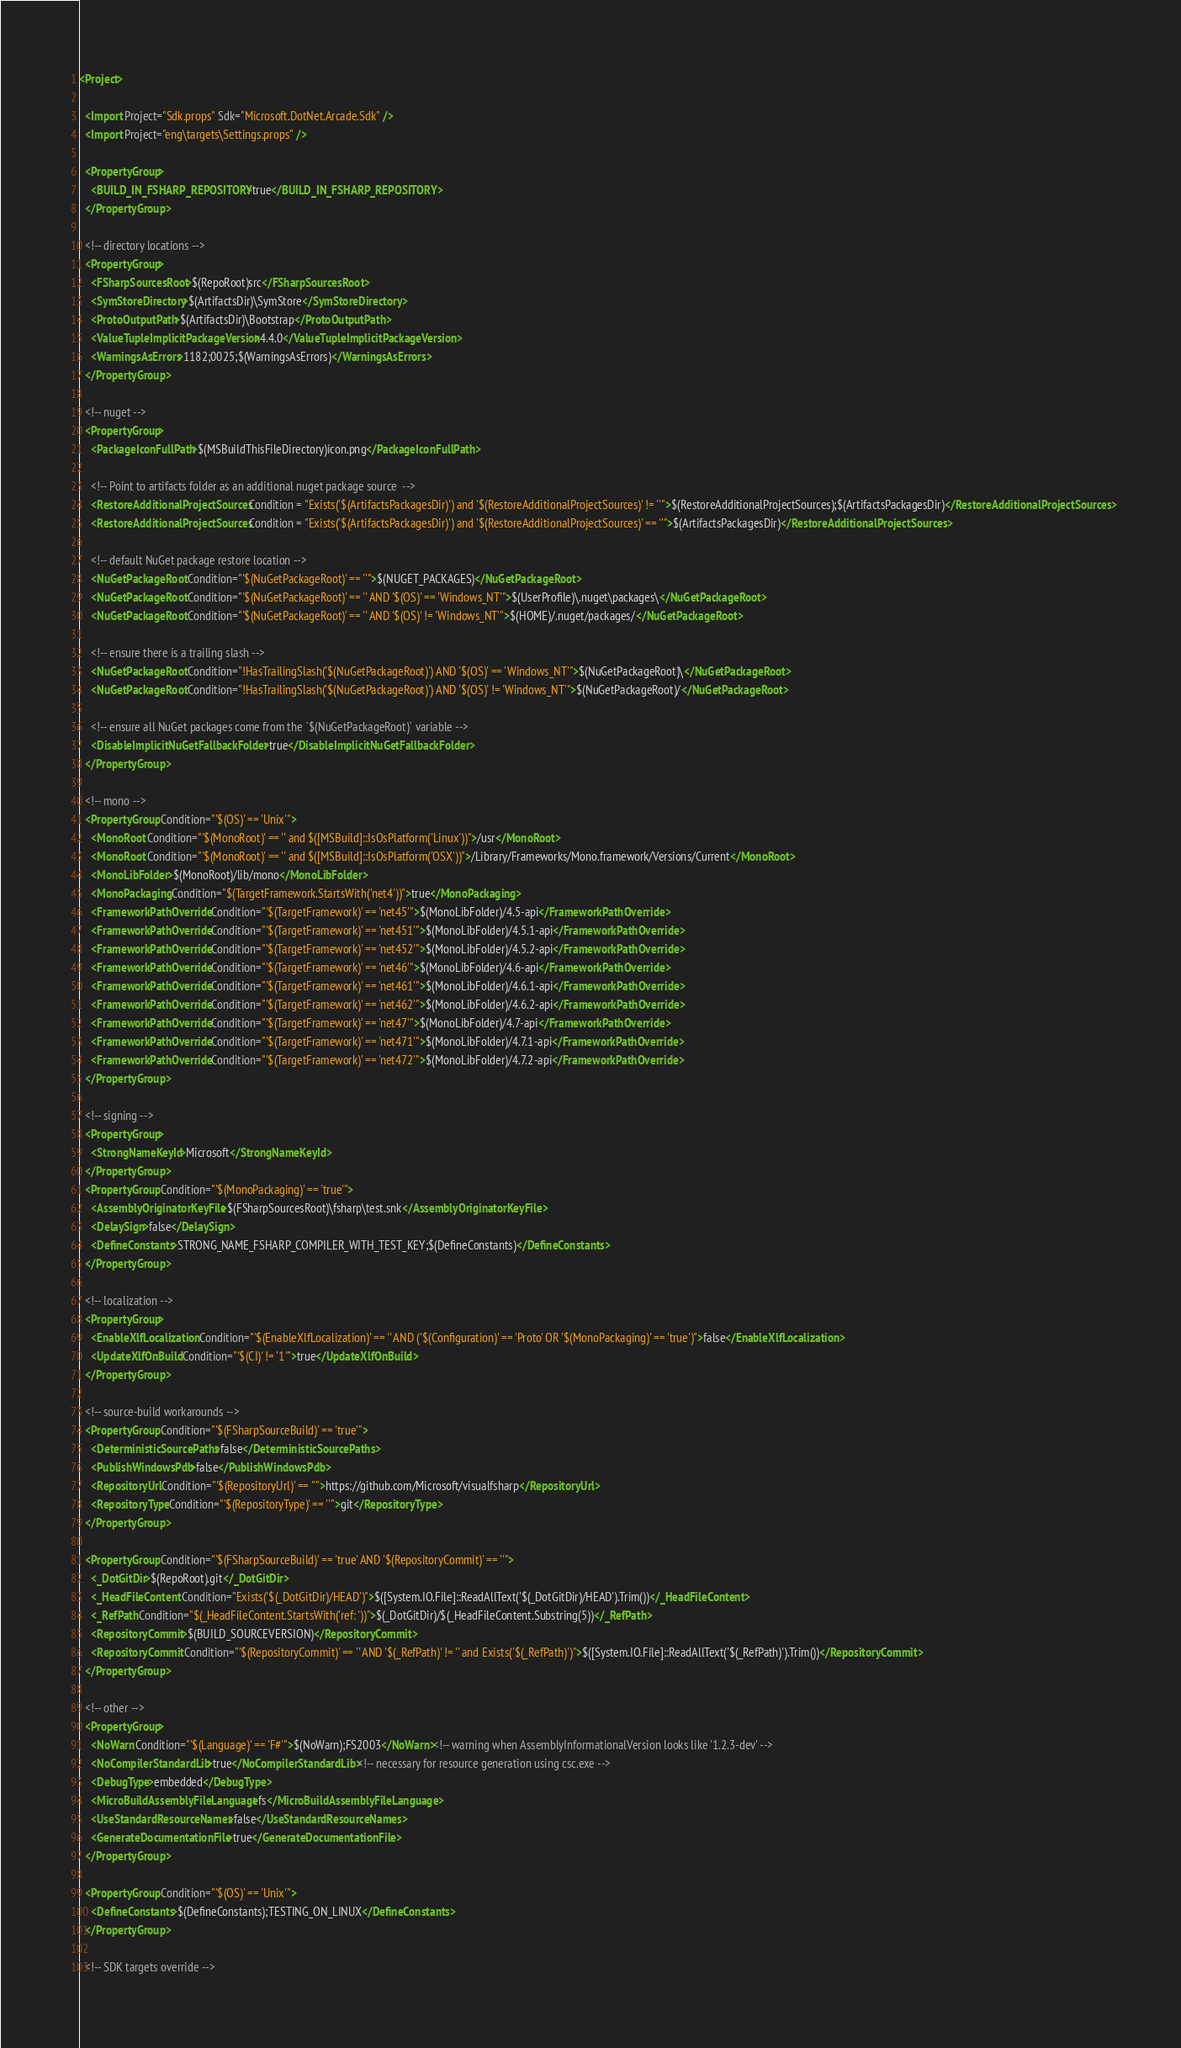<code> <loc_0><loc_0><loc_500><loc_500><_XML_><Project>

  <Import Project="Sdk.props" Sdk="Microsoft.DotNet.Arcade.Sdk" />
  <Import Project="eng\targets\Settings.props" />

  <PropertyGroup>
    <BUILD_IN_FSHARP_REPOSITORY>true</BUILD_IN_FSHARP_REPOSITORY>
  </PropertyGroup>

  <!-- directory locations -->
  <PropertyGroup>
    <FSharpSourcesRoot>$(RepoRoot)src</FSharpSourcesRoot>
    <SymStoreDirectory>$(ArtifactsDir)\SymStore</SymStoreDirectory>
    <ProtoOutputPath>$(ArtifactsDir)\Bootstrap</ProtoOutputPath>
    <ValueTupleImplicitPackageVersion>4.4.0</ValueTupleImplicitPackageVersion>
    <WarningsAsErrors>1182;0025;$(WarningsAsErrors)</WarningsAsErrors>
  </PropertyGroup>

  <!-- nuget -->
  <PropertyGroup>
    <PackageIconFullPath>$(MSBuildThisFileDirectory)icon.png</PackageIconFullPath>

    <!-- Point to artifacts folder as an additional nuget package source  -->
    <RestoreAdditionalProjectSources Condition = "Exists('$(ArtifactsPackagesDir)') and '$(RestoreAdditionalProjectSources)' != ''">$(RestoreAdditionalProjectSources);$(ArtifactsPackagesDir)</RestoreAdditionalProjectSources>
    <RestoreAdditionalProjectSources Condition = "Exists('$(ArtifactsPackagesDir)') and '$(RestoreAdditionalProjectSources)' == ''">$(ArtifactsPackagesDir)</RestoreAdditionalProjectSources>

    <!-- default NuGet package restore location -->
    <NuGetPackageRoot Condition="'$(NuGetPackageRoot)' == ''">$(NUGET_PACKAGES)</NuGetPackageRoot>
    <NuGetPackageRoot Condition="'$(NuGetPackageRoot)' == '' AND '$(OS)' == 'Windows_NT'">$(UserProfile)\.nuget\packages\</NuGetPackageRoot>
    <NuGetPackageRoot Condition="'$(NuGetPackageRoot)' == '' AND '$(OS)' != 'Windows_NT'">$(HOME)/.nuget/packages/</NuGetPackageRoot>

    <!-- ensure there is a trailing slash -->
    <NuGetPackageRoot Condition="!HasTrailingSlash('$(NuGetPackageRoot)') AND '$(OS)' == 'Windows_NT'">$(NuGetPackageRoot)\</NuGetPackageRoot>
    <NuGetPackageRoot Condition="!HasTrailingSlash('$(NuGetPackageRoot)') AND '$(OS)' != 'Windows_NT'">$(NuGetPackageRoot)/</NuGetPackageRoot>

    <!-- ensure all NuGet packages come from the `$(NuGetPackageRoot)` variable -->
    <DisableImplicitNuGetFallbackFolder>true</DisableImplicitNuGetFallbackFolder>
  </PropertyGroup>

  <!-- mono -->
  <PropertyGroup Condition="'$(OS)' == 'Unix'">
    <MonoRoot Condition="'$(MonoRoot)' == '' and $([MSBuild]::IsOsPlatform('Linux'))">/usr</MonoRoot>
    <MonoRoot Condition="'$(MonoRoot)' == '' and $([MSBuild]::IsOsPlatform('OSX'))">/Library/Frameworks/Mono.framework/Versions/Current</MonoRoot>
    <MonoLibFolder>$(MonoRoot)/lib/mono</MonoLibFolder>
    <MonoPackaging Condition="$(TargetFramework.StartsWith('net4'))">true</MonoPackaging>
    <FrameworkPathOverride Condition="'$(TargetFramework)' == 'net45'">$(MonoLibFolder)/4.5-api</FrameworkPathOverride>
    <FrameworkPathOverride Condition="'$(TargetFramework)' == 'net451'">$(MonoLibFolder)/4.5.1-api</FrameworkPathOverride>
    <FrameworkPathOverride Condition="'$(TargetFramework)' == 'net452'">$(MonoLibFolder)/4.5.2-api</FrameworkPathOverride>
    <FrameworkPathOverride Condition="'$(TargetFramework)' == 'net46'">$(MonoLibFolder)/4.6-api</FrameworkPathOverride>
    <FrameworkPathOverride Condition="'$(TargetFramework)' == 'net461'">$(MonoLibFolder)/4.6.1-api</FrameworkPathOverride>
    <FrameworkPathOverride Condition="'$(TargetFramework)' == 'net462'">$(MonoLibFolder)/4.6.2-api</FrameworkPathOverride>
    <FrameworkPathOverride Condition="'$(TargetFramework)' == 'net47'">$(MonoLibFolder)/4.7-api</FrameworkPathOverride>
    <FrameworkPathOverride Condition="'$(TargetFramework)' == 'net471'">$(MonoLibFolder)/4.7.1-api</FrameworkPathOverride>
    <FrameworkPathOverride Condition="'$(TargetFramework)' == 'net472'">$(MonoLibFolder)/4.7.2-api</FrameworkPathOverride>
  </PropertyGroup>

  <!-- signing -->
  <PropertyGroup>
    <StrongNameKeyId>Microsoft</StrongNameKeyId>
  </PropertyGroup>
  <PropertyGroup Condition="'$(MonoPackaging)' == 'true'">
    <AssemblyOriginatorKeyFile>$(FSharpSourcesRoot)\fsharp\test.snk</AssemblyOriginatorKeyFile>
    <DelaySign>false</DelaySign>
    <DefineConstants>STRONG_NAME_FSHARP_COMPILER_WITH_TEST_KEY;$(DefineConstants)</DefineConstants>
  </PropertyGroup>

  <!-- localization -->
  <PropertyGroup>
    <EnableXlfLocalization Condition="'$(EnableXlfLocalization)' == '' AND ('$(Configuration)' == 'Proto' OR '$(MonoPackaging)' == 'true')">false</EnableXlfLocalization>
    <UpdateXlfOnBuild Condition="'$(CI)' != '1'">true</UpdateXlfOnBuild>
  </PropertyGroup>

  <!-- source-build workarounds -->
  <PropertyGroup Condition="'$(FSharpSourceBuild)' == 'true'">
    <DeterministicSourcePaths>false</DeterministicSourcePaths>
    <PublishWindowsPdb>false</PublishWindowsPdb>
    <RepositoryUrl Condition="'$(RepositoryUrl)' == ''">https://github.com/Microsoft/visualfsharp</RepositoryUrl>
    <RepositoryType Condition="'$(RepositoryType)' == ''">git</RepositoryType>
  </PropertyGroup>

  <PropertyGroup Condition="'$(FSharpSourceBuild)' == 'true' AND '$(RepositoryCommit)' == ''">
    <_DotGitDir>$(RepoRoot).git</_DotGitDir>
    <_HeadFileContent Condition="Exists('$(_DotGitDir)/HEAD')">$([System.IO.File]::ReadAllText('$(_DotGitDir)/HEAD').Trim())</_HeadFileContent>
    <_RefPath Condition="$(_HeadFileContent.StartsWith('ref: '))">$(_DotGitDir)/$(_HeadFileContent.Substring(5))</_RefPath>
    <RepositoryCommit>$(BUILD_SOURCEVERSION)</RepositoryCommit>
    <RepositoryCommit Condition="'$(RepositoryCommit)' == '' AND '$(_RefPath)' != '' and Exists('$(_RefPath)')">$([System.IO.File]::ReadAllText('$(_RefPath)').Trim())</RepositoryCommit>
  </PropertyGroup>

  <!-- other -->
  <PropertyGroup>
    <NoWarn Condition="'$(Language)' == 'F#'">$(NoWarn);FS2003</NoWarn><!-- warning when AssemblyInformationalVersion looks like '1.2.3-dev' -->
    <NoCompilerStandardLib>true</NoCompilerStandardLib><!-- necessary for resource generation using csc.exe -->
    <DebugType>embedded</DebugType>
    <MicroBuildAssemblyFileLanguage>fs</MicroBuildAssemblyFileLanguage>
    <UseStandardResourceNames>false</UseStandardResourceNames>
    <GenerateDocumentationFile>true</GenerateDocumentationFile>
  </PropertyGroup>

  <PropertyGroup Condition="'$(OS)' == 'Unix'">
    <DefineConstants>$(DefineConstants);TESTING_ON_LINUX</DefineConstants>
  </PropertyGroup>

  <!-- SDK targets override --></code> 